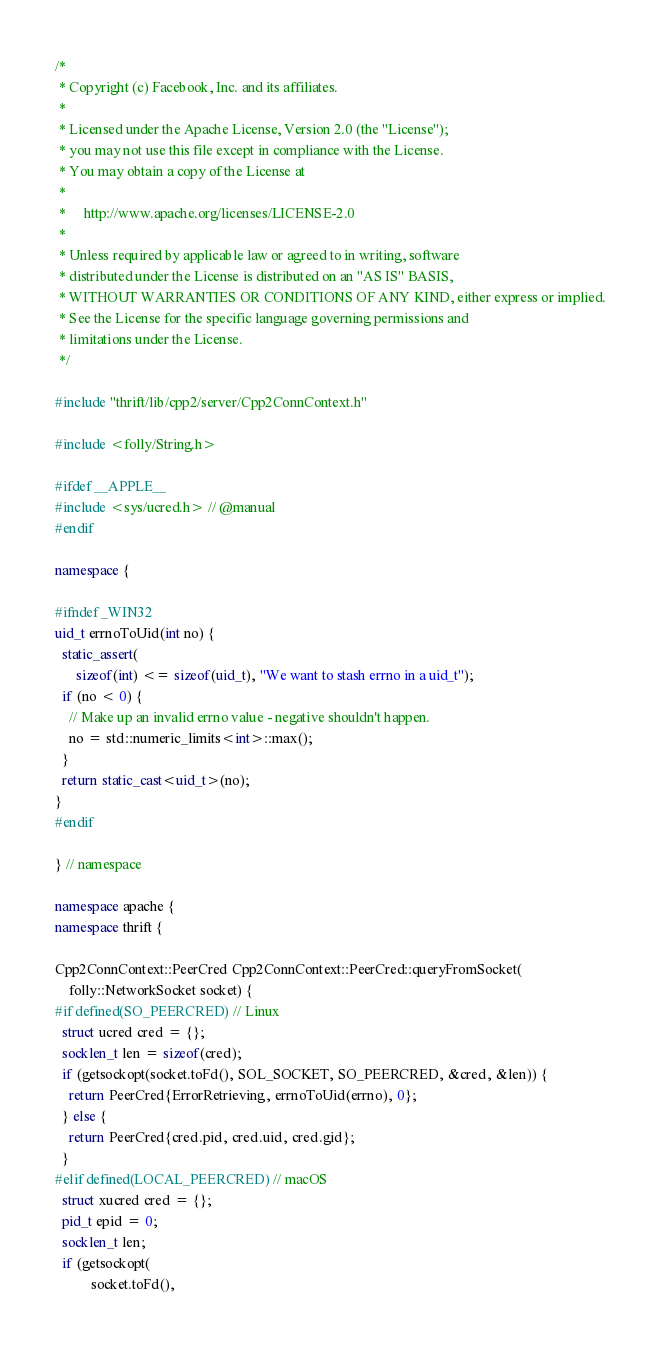<code> <loc_0><loc_0><loc_500><loc_500><_C++_>/*
 * Copyright (c) Facebook, Inc. and its affiliates.
 *
 * Licensed under the Apache License, Version 2.0 (the "License");
 * you may not use this file except in compliance with the License.
 * You may obtain a copy of the License at
 *
 *     http://www.apache.org/licenses/LICENSE-2.0
 *
 * Unless required by applicable law or agreed to in writing, software
 * distributed under the License is distributed on an "AS IS" BASIS,
 * WITHOUT WARRANTIES OR CONDITIONS OF ANY KIND, either express or implied.
 * See the License for the specific language governing permissions and
 * limitations under the License.
 */

#include "thrift/lib/cpp2/server/Cpp2ConnContext.h"

#include <folly/String.h>

#ifdef __APPLE__
#include <sys/ucred.h> // @manual
#endif

namespace {

#ifndef _WIN32
uid_t errnoToUid(int no) {
  static_assert(
      sizeof(int) <= sizeof(uid_t), "We want to stash errno in a uid_t");
  if (no < 0) {
    // Make up an invalid errno value - negative shouldn't happen.
    no = std::numeric_limits<int>::max();
  }
  return static_cast<uid_t>(no);
}
#endif

} // namespace

namespace apache {
namespace thrift {

Cpp2ConnContext::PeerCred Cpp2ConnContext::PeerCred::queryFromSocket(
    folly::NetworkSocket socket) {
#if defined(SO_PEERCRED) // Linux
  struct ucred cred = {};
  socklen_t len = sizeof(cred);
  if (getsockopt(socket.toFd(), SOL_SOCKET, SO_PEERCRED, &cred, &len)) {
    return PeerCred{ErrorRetrieving, errnoToUid(errno), 0};
  } else {
    return PeerCred{cred.pid, cred.uid, cred.gid};
  }
#elif defined(LOCAL_PEERCRED) // macOS
  struct xucred cred = {};
  pid_t epid = 0;
  socklen_t len;
  if (getsockopt(
          socket.toFd(),</code> 